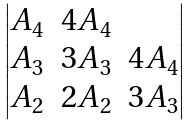<formula> <loc_0><loc_0><loc_500><loc_500>\begin{vmatrix} A _ { 4 } & 4 A _ { 4 } & \\ A _ { 3 } & 3 A _ { 3 } & 4 A _ { 4 } \\ A _ { 2 } & 2 A _ { 2 } & 3 A _ { 3 } \\ \end{vmatrix}</formula> 